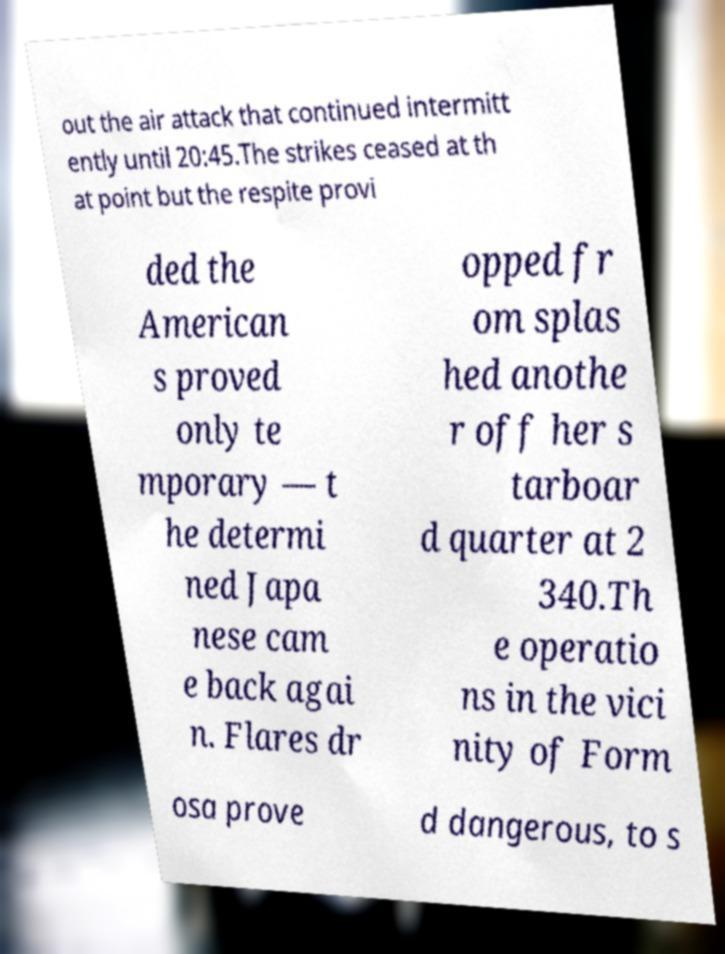What messages or text are displayed in this image? I need them in a readable, typed format. out the air attack that continued intermitt ently until 20:45.The strikes ceased at th at point but the respite provi ded the American s proved only te mporary — t he determi ned Japa nese cam e back agai n. Flares dr opped fr om splas hed anothe r off her s tarboar d quarter at 2 340.Th e operatio ns in the vici nity of Form osa prove d dangerous, to s 